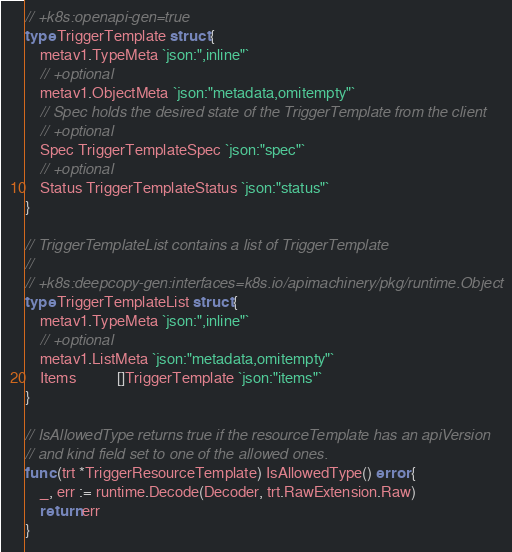<code> <loc_0><loc_0><loc_500><loc_500><_Go_>// +k8s:openapi-gen=true
type TriggerTemplate struct {
	metav1.TypeMeta `json:",inline"`
	// +optional
	metav1.ObjectMeta `json:"metadata,omitempty"`
	// Spec holds the desired state of the TriggerTemplate from the client
	// +optional
	Spec TriggerTemplateSpec `json:"spec"`
	// +optional
	Status TriggerTemplateStatus `json:"status"`
}

// TriggerTemplateList contains a list of TriggerTemplate
//
// +k8s:deepcopy-gen:interfaces=k8s.io/apimachinery/pkg/runtime.Object
type TriggerTemplateList struct {
	metav1.TypeMeta `json:",inline"`
	// +optional
	metav1.ListMeta `json:"metadata,omitempty"`
	Items           []TriggerTemplate `json:"items"`
}

// IsAllowedType returns true if the resourceTemplate has an apiVersion
// and kind field set to one of the allowed ones.
func (trt *TriggerResourceTemplate) IsAllowedType() error {
	_, err := runtime.Decode(Decoder, trt.RawExtension.Raw)
	return err
}
</code> 